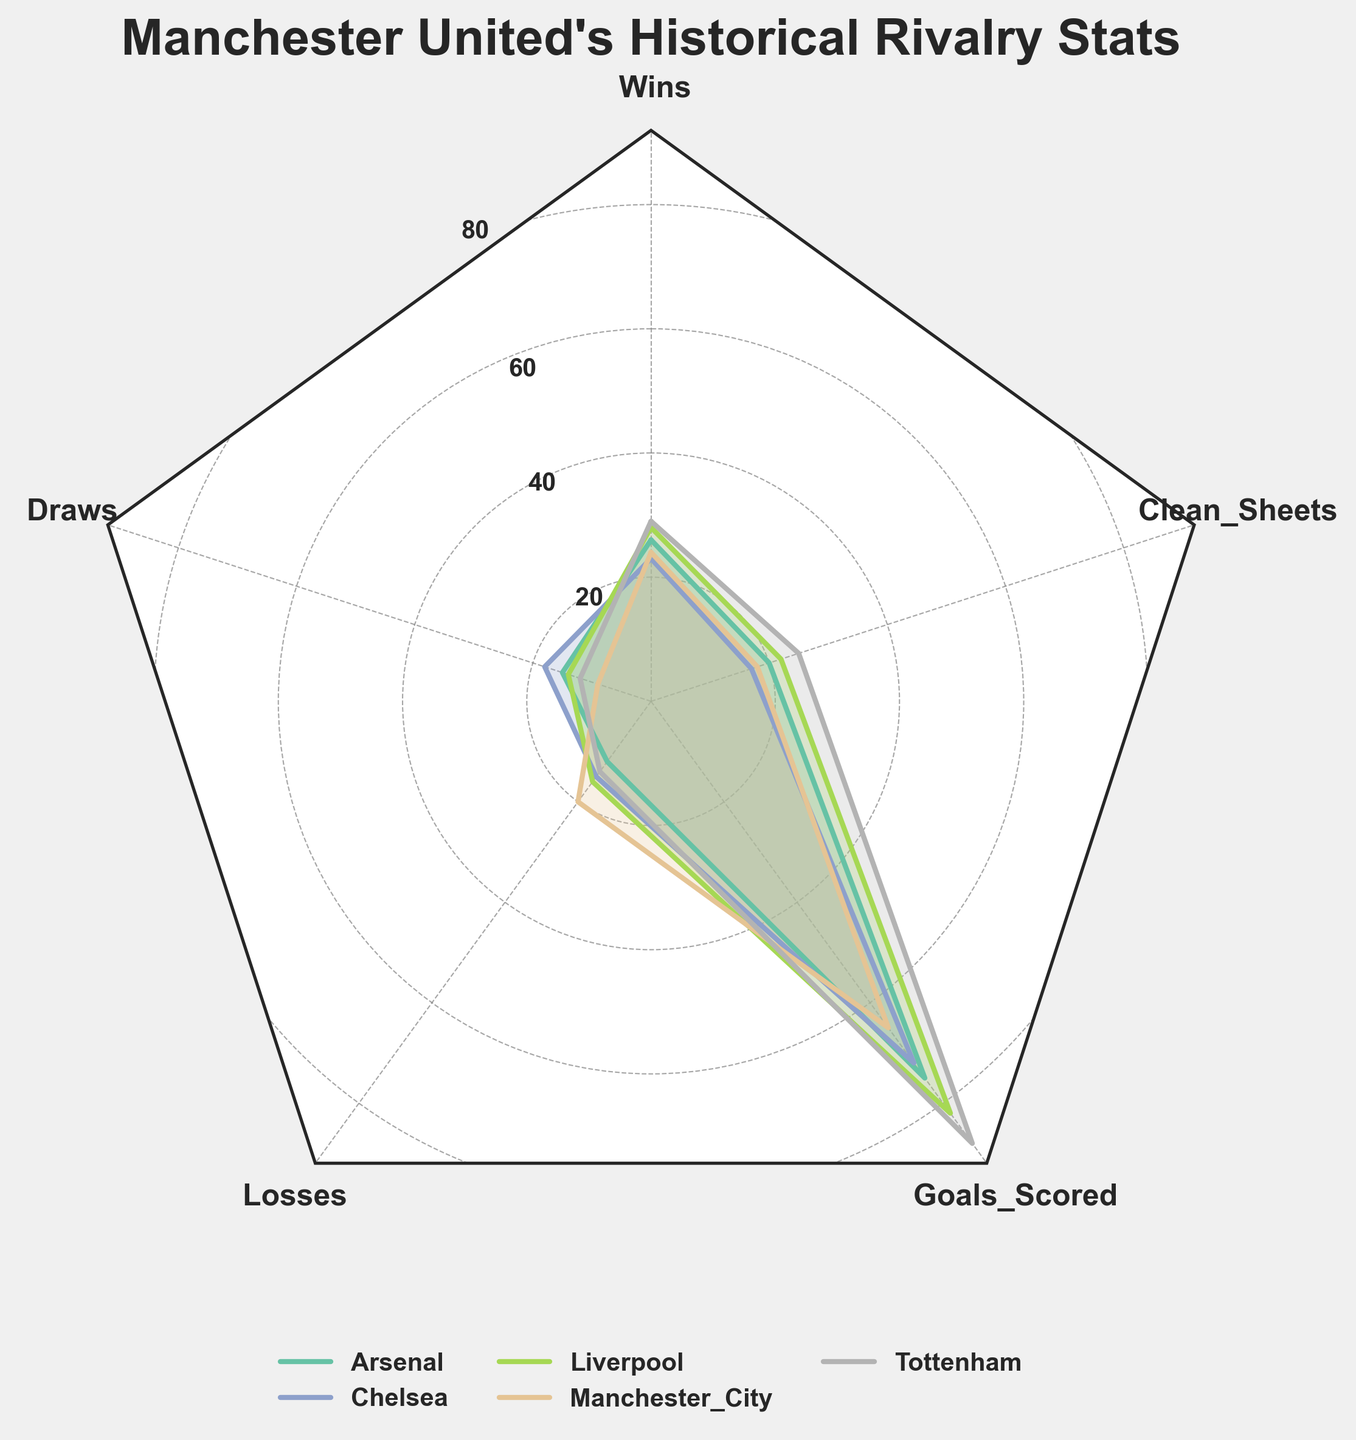What is the title of the radar chart? The title is typically located at the top of the chart and describes the main topic of the visualization. In this case, it should be "Manchester United's Historical Rivalry Stats."
Answer: Manchester United's Historical Rivalry Stats How many teams are represented in the radar chart? To determine the number of teams, one can simply count the unique plot lines or reference the legend that lists the teams.
Answer: 5 Which team has the highest number of wins against Manchester United? Analyze the segment labeled "Wins" in the radar chart. Look for the team whose plot line reaches the farthest in that direction. Tottenham has the highest value.
Answer: Tottenham Which team has the least number of clean sheets against Manchester United? Analyze the "Clean_Sheets" segment in the chart. Identify the team whose plot line reaches the least in that direction.
Answer: Chelsea How many goals has Manchester United scored against Liverpool in total? Reference the radar chart's "Goals_Scored" segment and look for Liverpool's corresponding plot. Note the numerical value listed for this data point.
Answer: 82 Which team has the most balanced (less spiky and more uniform) performance against Manchester United across all metrics? Observe the radar chart and look for a plot that shows the most evenly distributed lines without larger spikes in any specific direction. Chelsea appears to have a more balanced performance.
Answer: Chelsea What's the average number of losses Manchester United has against the top 5 teams? Locate the "Losses" segment for each team on the radar chart. Add the values (12+15+16+20+14) and divide by the number of teams (5) to find the average.
Answer: \( \frac{12+15+16+20+14}{5} = 15.4 \) Which team has scored the most goals against Manchester United? Look at the "Goals_Scored" segment of the radar chart. Identify the team with the value that reaches the farthest along that radial line. Tottenham has the highest value.
Answer: Tottenham How does Manchester United's clean sheet count compare between Arsenal and Manchester City? Compare the "Clean_Sheets" segment for both teams. Arsenal has 20 clean sheets while Manchester City has 18. Determine which value is greater.
Answer: Arsenal has more clean sheets 